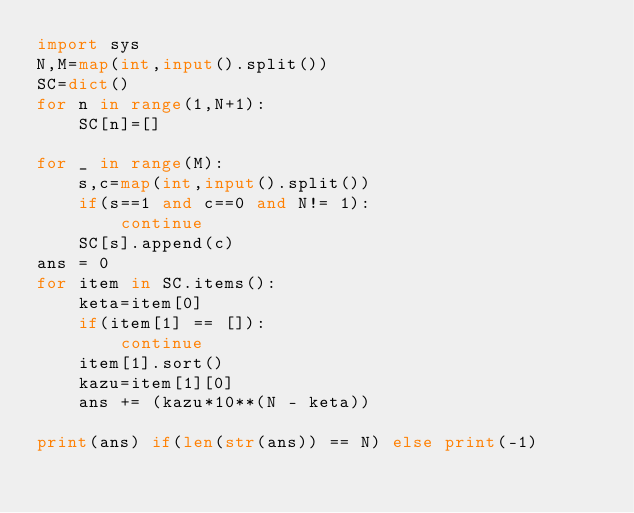<code> <loc_0><loc_0><loc_500><loc_500><_Python_>import sys
N,M=map(int,input().split())
SC=dict()
for n in range(1,N+1):
    SC[n]=[]

for _ in range(M):
    s,c=map(int,input().split())
    if(s==1 and c==0 and N!= 1):
        continue
    SC[s].append(c)
ans = 0
for item in SC.items():
    keta=item[0]
    if(item[1] == []):
        continue
    item[1].sort()
    kazu=item[1][0]
    ans += (kazu*10**(N - keta))

print(ans) if(len(str(ans)) == N) else print(-1)
    </code> 